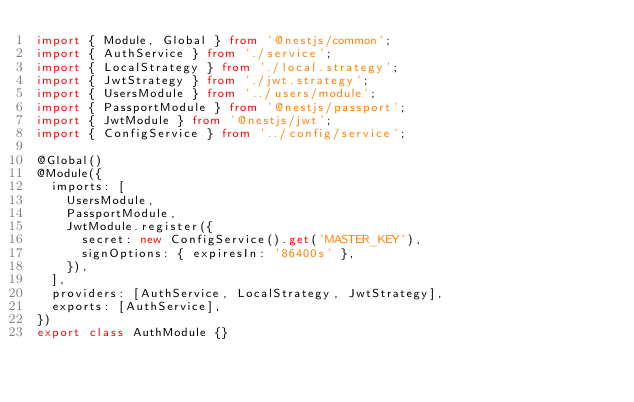Convert code to text. <code><loc_0><loc_0><loc_500><loc_500><_TypeScript_>import { Module, Global } from '@nestjs/common';
import { AuthService } from './service';
import { LocalStrategy } from './local.strategy';
import { JwtStrategy } from './jwt.strategy';
import { UsersModule } from '../users/module';
import { PassportModule } from '@nestjs/passport';
import { JwtModule } from '@nestjs/jwt';
import { ConfigService } from '../config/service';

@Global()
@Module({
  imports: [
    UsersModule,
    PassportModule,
    JwtModule.register({
      secret: new ConfigService().get('MASTER_KEY'),
      signOptions: { expiresIn: '86400s' },
    }),
  ],
  providers: [AuthService, LocalStrategy, JwtStrategy],
  exports: [AuthService],
})
export class AuthModule {}
</code> 